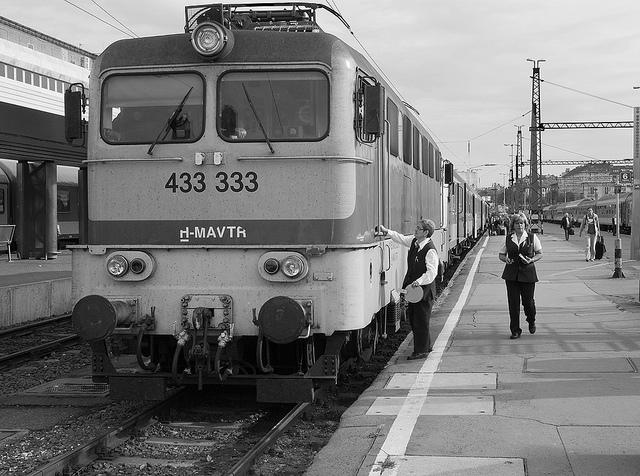What number is on the front of the train?
Give a very brief answer. 433 333. Why would someone wash the train?
Keep it brief. Keep it clean. Is the photo colored?
Give a very brief answer. No. What kind of train is this?
Write a very short answer. Passenger. 